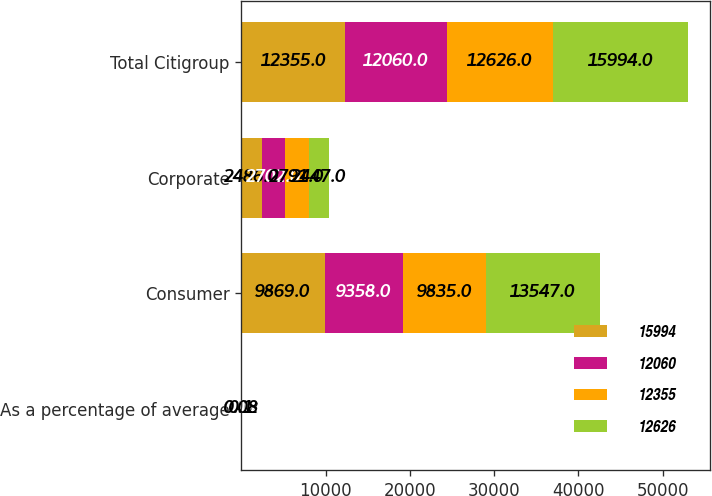<chart> <loc_0><loc_0><loc_500><loc_500><stacked_bar_chart><ecel><fcel>As a percentage of average<fcel>Consumer<fcel>Corporate<fcel>Total Citigroup<nl><fcel>15994<fcel>0.12<fcel>9869<fcel>2486<fcel>12355<nl><fcel>12060<fcel>0.17<fcel>9358<fcel>2702<fcel>12060<nl><fcel>12355<fcel>0.08<fcel>9835<fcel>2791<fcel>12626<nl><fcel>12626<fcel>0.1<fcel>13547<fcel>2447<fcel>15994<nl></chart> 